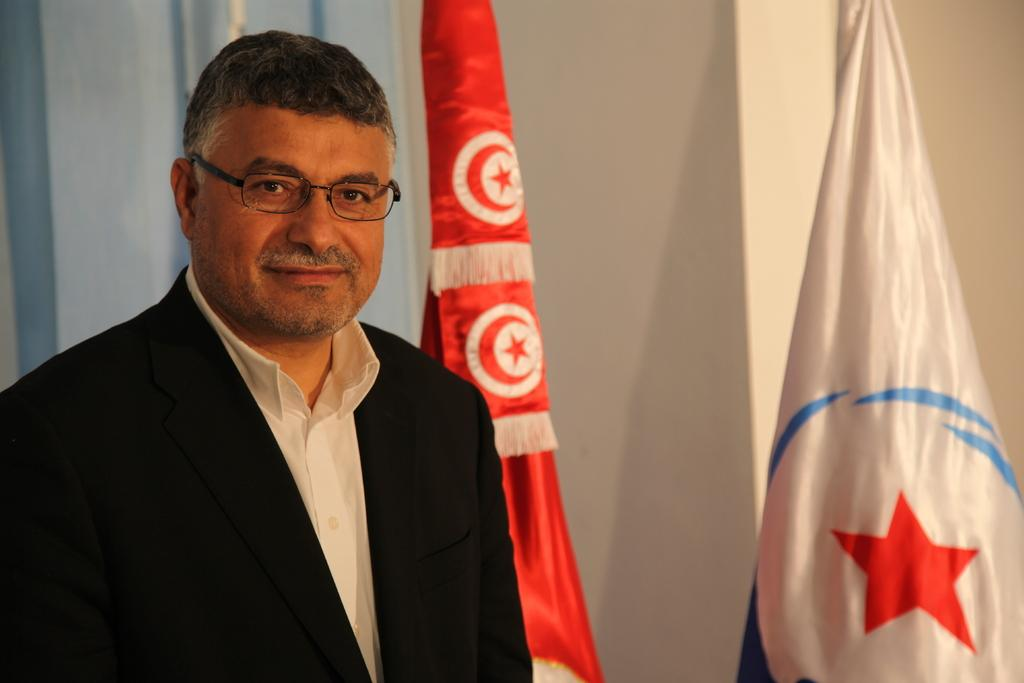Who is present in the image? There is a man in the image. What is the man's facial expression? The man is smiling. What can be seen on the right side of the image? There are two flags on the right side of the image. What is visible in the background of the image? There is a wall in the background of the image. What type of paint is being used on the linen in the image? There is no paint or linen present in the image. How many horses are visible in the image? There are no horses visible in the image. 